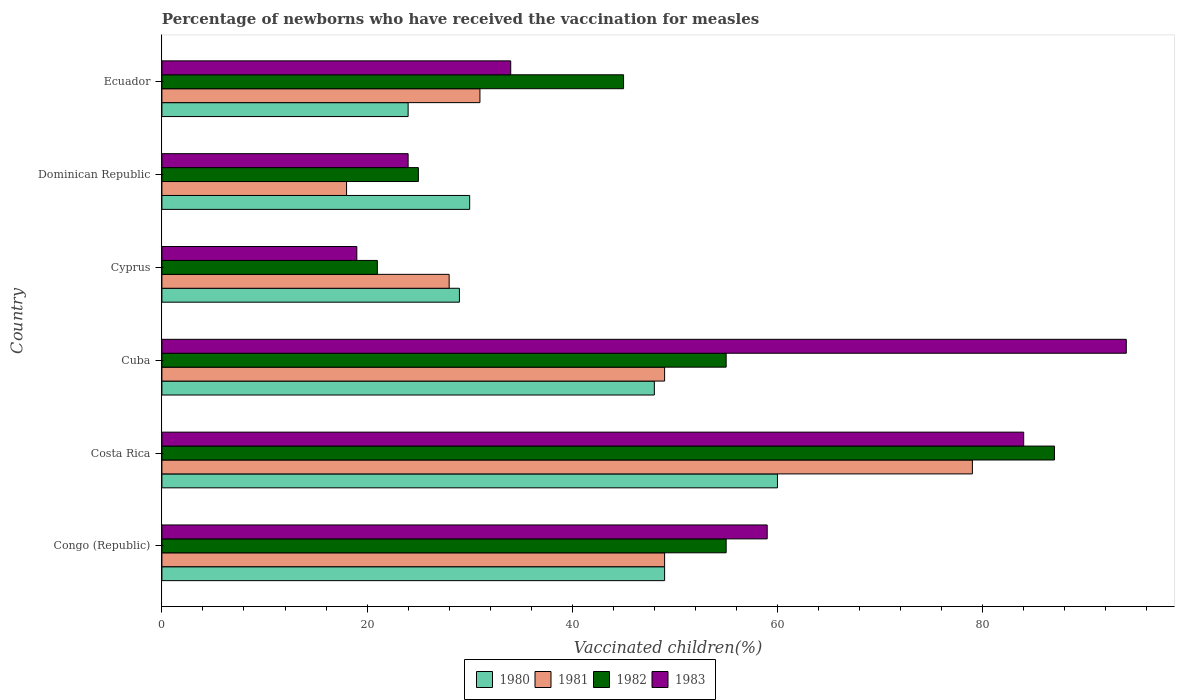How many different coloured bars are there?
Give a very brief answer. 4. Are the number of bars per tick equal to the number of legend labels?
Offer a terse response. Yes. Are the number of bars on each tick of the Y-axis equal?
Keep it short and to the point. Yes. How many bars are there on the 2nd tick from the top?
Provide a succinct answer. 4. What is the label of the 5th group of bars from the top?
Provide a succinct answer. Costa Rica. In how many cases, is the number of bars for a given country not equal to the number of legend labels?
Make the answer very short. 0. What is the percentage of vaccinated children in 1983 in Cyprus?
Offer a very short reply. 19. Across all countries, what is the minimum percentage of vaccinated children in 1982?
Offer a terse response. 21. In which country was the percentage of vaccinated children in 1983 minimum?
Keep it short and to the point. Cyprus. What is the total percentage of vaccinated children in 1980 in the graph?
Ensure brevity in your answer.  240. What is the average percentage of vaccinated children in 1982 per country?
Give a very brief answer. 48. What is the difference between the percentage of vaccinated children in 1980 and percentage of vaccinated children in 1982 in Congo (Republic)?
Offer a very short reply. -6. In how many countries, is the percentage of vaccinated children in 1981 greater than 44 %?
Ensure brevity in your answer.  3. What is the ratio of the percentage of vaccinated children in 1982 in Congo (Republic) to that in Costa Rica?
Offer a very short reply. 0.63. What is the difference between the highest and the second highest percentage of vaccinated children in 1980?
Your answer should be compact. 11. What is the difference between the highest and the lowest percentage of vaccinated children in 1981?
Provide a short and direct response. 61. In how many countries, is the percentage of vaccinated children in 1981 greater than the average percentage of vaccinated children in 1981 taken over all countries?
Your response must be concise. 3. Is the sum of the percentage of vaccinated children in 1980 in Congo (Republic) and Ecuador greater than the maximum percentage of vaccinated children in 1982 across all countries?
Offer a very short reply. No. What does the 2nd bar from the bottom in Cuba represents?
Offer a very short reply. 1981. How many countries are there in the graph?
Your answer should be compact. 6. What is the difference between two consecutive major ticks on the X-axis?
Give a very brief answer. 20. Does the graph contain any zero values?
Your response must be concise. No. Does the graph contain grids?
Offer a terse response. No. How many legend labels are there?
Offer a very short reply. 4. What is the title of the graph?
Keep it short and to the point. Percentage of newborns who have received the vaccination for measles. Does "2014" appear as one of the legend labels in the graph?
Provide a short and direct response. No. What is the label or title of the X-axis?
Provide a succinct answer. Vaccinated children(%). What is the Vaccinated children(%) of 1981 in Congo (Republic)?
Offer a very short reply. 49. What is the Vaccinated children(%) of 1983 in Congo (Republic)?
Offer a terse response. 59. What is the Vaccinated children(%) in 1980 in Costa Rica?
Provide a succinct answer. 60. What is the Vaccinated children(%) of 1981 in Costa Rica?
Keep it short and to the point. 79. What is the Vaccinated children(%) in 1980 in Cuba?
Your answer should be very brief. 48. What is the Vaccinated children(%) of 1981 in Cuba?
Keep it short and to the point. 49. What is the Vaccinated children(%) in 1983 in Cuba?
Ensure brevity in your answer.  94. What is the Vaccinated children(%) of 1980 in Cyprus?
Ensure brevity in your answer.  29. What is the Vaccinated children(%) in 1981 in Cyprus?
Provide a succinct answer. 28. What is the Vaccinated children(%) in 1982 in Cyprus?
Your answer should be compact. 21. What is the Vaccinated children(%) in 1981 in Dominican Republic?
Your response must be concise. 18. What is the Vaccinated children(%) in 1982 in Dominican Republic?
Offer a very short reply. 25. What is the Vaccinated children(%) in 1980 in Ecuador?
Give a very brief answer. 24. What is the Vaccinated children(%) in 1982 in Ecuador?
Ensure brevity in your answer.  45. What is the Vaccinated children(%) in 1983 in Ecuador?
Make the answer very short. 34. Across all countries, what is the maximum Vaccinated children(%) in 1980?
Your answer should be very brief. 60. Across all countries, what is the maximum Vaccinated children(%) of 1981?
Offer a very short reply. 79. Across all countries, what is the maximum Vaccinated children(%) of 1982?
Your answer should be very brief. 87. Across all countries, what is the maximum Vaccinated children(%) of 1983?
Provide a succinct answer. 94. Across all countries, what is the minimum Vaccinated children(%) of 1982?
Your answer should be compact. 21. What is the total Vaccinated children(%) in 1980 in the graph?
Ensure brevity in your answer.  240. What is the total Vaccinated children(%) of 1981 in the graph?
Your answer should be compact. 254. What is the total Vaccinated children(%) of 1982 in the graph?
Give a very brief answer. 288. What is the total Vaccinated children(%) in 1983 in the graph?
Offer a very short reply. 314. What is the difference between the Vaccinated children(%) in 1981 in Congo (Republic) and that in Costa Rica?
Provide a short and direct response. -30. What is the difference between the Vaccinated children(%) in 1982 in Congo (Republic) and that in Costa Rica?
Provide a succinct answer. -32. What is the difference between the Vaccinated children(%) of 1983 in Congo (Republic) and that in Cuba?
Offer a very short reply. -35. What is the difference between the Vaccinated children(%) in 1981 in Congo (Republic) and that in Cyprus?
Make the answer very short. 21. What is the difference between the Vaccinated children(%) of 1980 in Congo (Republic) and that in Dominican Republic?
Provide a succinct answer. 19. What is the difference between the Vaccinated children(%) in 1981 in Congo (Republic) and that in Dominican Republic?
Offer a very short reply. 31. What is the difference between the Vaccinated children(%) in 1982 in Congo (Republic) and that in Dominican Republic?
Make the answer very short. 30. What is the difference between the Vaccinated children(%) in 1983 in Congo (Republic) and that in Dominican Republic?
Provide a short and direct response. 35. What is the difference between the Vaccinated children(%) in 1980 in Congo (Republic) and that in Ecuador?
Your response must be concise. 25. What is the difference between the Vaccinated children(%) in 1981 in Congo (Republic) and that in Ecuador?
Your answer should be compact. 18. What is the difference between the Vaccinated children(%) of 1980 in Costa Rica and that in Cuba?
Ensure brevity in your answer.  12. What is the difference between the Vaccinated children(%) in 1981 in Costa Rica and that in Cuba?
Make the answer very short. 30. What is the difference between the Vaccinated children(%) in 1983 in Costa Rica and that in Cuba?
Make the answer very short. -10. What is the difference between the Vaccinated children(%) in 1983 in Costa Rica and that in Cyprus?
Make the answer very short. 65. What is the difference between the Vaccinated children(%) of 1980 in Costa Rica and that in Dominican Republic?
Give a very brief answer. 30. What is the difference between the Vaccinated children(%) of 1982 in Costa Rica and that in Dominican Republic?
Your response must be concise. 62. What is the difference between the Vaccinated children(%) of 1983 in Costa Rica and that in Dominican Republic?
Your answer should be very brief. 60. What is the difference between the Vaccinated children(%) in 1981 in Costa Rica and that in Ecuador?
Keep it short and to the point. 48. What is the difference between the Vaccinated children(%) in 1983 in Costa Rica and that in Ecuador?
Your response must be concise. 50. What is the difference between the Vaccinated children(%) of 1980 in Cuba and that in Dominican Republic?
Your answer should be compact. 18. What is the difference between the Vaccinated children(%) of 1982 in Cuba and that in Dominican Republic?
Ensure brevity in your answer.  30. What is the difference between the Vaccinated children(%) in 1980 in Cuba and that in Ecuador?
Your answer should be very brief. 24. What is the difference between the Vaccinated children(%) in 1981 in Cuba and that in Ecuador?
Keep it short and to the point. 18. What is the difference between the Vaccinated children(%) of 1982 in Cuba and that in Ecuador?
Your answer should be very brief. 10. What is the difference between the Vaccinated children(%) in 1983 in Cuba and that in Ecuador?
Your answer should be very brief. 60. What is the difference between the Vaccinated children(%) in 1982 in Cyprus and that in Dominican Republic?
Provide a succinct answer. -4. What is the difference between the Vaccinated children(%) of 1980 in Cyprus and that in Ecuador?
Your answer should be compact. 5. What is the difference between the Vaccinated children(%) of 1981 in Cyprus and that in Ecuador?
Your answer should be compact. -3. What is the difference between the Vaccinated children(%) in 1982 in Cyprus and that in Ecuador?
Provide a short and direct response. -24. What is the difference between the Vaccinated children(%) in 1983 in Cyprus and that in Ecuador?
Provide a succinct answer. -15. What is the difference between the Vaccinated children(%) in 1981 in Dominican Republic and that in Ecuador?
Provide a succinct answer. -13. What is the difference between the Vaccinated children(%) in 1983 in Dominican Republic and that in Ecuador?
Keep it short and to the point. -10. What is the difference between the Vaccinated children(%) in 1980 in Congo (Republic) and the Vaccinated children(%) in 1981 in Costa Rica?
Provide a succinct answer. -30. What is the difference between the Vaccinated children(%) in 1980 in Congo (Republic) and the Vaccinated children(%) in 1982 in Costa Rica?
Provide a succinct answer. -38. What is the difference between the Vaccinated children(%) in 1980 in Congo (Republic) and the Vaccinated children(%) in 1983 in Costa Rica?
Provide a succinct answer. -35. What is the difference between the Vaccinated children(%) of 1981 in Congo (Republic) and the Vaccinated children(%) of 1982 in Costa Rica?
Make the answer very short. -38. What is the difference between the Vaccinated children(%) in 1981 in Congo (Republic) and the Vaccinated children(%) in 1983 in Costa Rica?
Offer a terse response. -35. What is the difference between the Vaccinated children(%) in 1982 in Congo (Republic) and the Vaccinated children(%) in 1983 in Costa Rica?
Your answer should be very brief. -29. What is the difference between the Vaccinated children(%) of 1980 in Congo (Republic) and the Vaccinated children(%) of 1983 in Cuba?
Give a very brief answer. -45. What is the difference between the Vaccinated children(%) of 1981 in Congo (Republic) and the Vaccinated children(%) of 1982 in Cuba?
Keep it short and to the point. -6. What is the difference between the Vaccinated children(%) in 1981 in Congo (Republic) and the Vaccinated children(%) in 1983 in Cuba?
Give a very brief answer. -45. What is the difference between the Vaccinated children(%) of 1982 in Congo (Republic) and the Vaccinated children(%) of 1983 in Cuba?
Ensure brevity in your answer.  -39. What is the difference between the Vaccinated children(%) of 1980 in Congo (Republic) and the Vaccinated children(%) of 1983 in Cyprus?
Give a very brief answer. 30. What is the difference between the Vaccinated children(%) of 1981 in Congo (Republic) and the Vaccinated children(%) of 1982 in Cyprus?
Your answer should be compact. 28. What is the difference between the Vaccinated children(%) of 1981 in Congo (Republic) and the Vaccinated children(%) of 1983 in Cyprus?
Offer a terse response. 30. What is the difference between the Vaccinated children(%) of 1982 in Congo (Republic) and the Vaccinated children(%) of 1983 in Cyprus?
Keep it short and to the point. 36. What is the difference between the Vaccinated children(%) of 1980 in Congo (Republic) and the Vaccinated children(%) of 1981 in Dominican Republic?
Give a very brief answer. 31. What is the difference between the Vaccinated children(%) of 1980 in Congo (Republic) and the Vaccinated children(%) of 1982 in Dominican Republic?
Your response must be concise. 24. What is the difference between the Vaccinated children(%) in 1981 in Congo (Republic) and the Vaccinated children(%) in 1983 in Dominican Republic?
Make the answer very short. 25. What is the difference between the Vaccinated children(%) in 1982 in Congo (Republic) and the Vaccinated children(%) in 1983 in Dominican Republic?
Keep it short and to the point. 31. What is the difference between the Vaccinated children(%) in 1980 in Congo (Republic) and the Vaccinated children(%) in 1981 in Ecuador?
Provide a short and direct response. 18. What is the difference between the Vaccinated children(%) of 1980 in Congo (Republic) and the Vaccinated children(%) of 1982 in Ecuador?
Make the answer very short. 4. What is the difference between the Vaccinated children(%) of 1980 in Congo (Republic) and the Vaccinated children(%) of 1983 in Ecuador?
Give a very brief answer. 15. What is the difference between the Vaccinated children(%) in 1981 in Congo (Republic) and the Vaccinated children(%) in 1983 in Ecuador?
Make the answer very short. 15. What is the difference between the Vaccinated children(%) of 1980 in Costa Rica and the Vaccinated children(%) of 1981 in Cuba?
Provide a short and direct response. 11. What is the difference between the Vaccinated children(%) of 1980 in Costa Rica and the Vaccinated children(%) of 1983 in Cuba?
Your answer should be compact. -34. What is the difference between the Vaccinated children(%) of 1981 in Costa Rica and the Vaccinated children(%) of 1982 in Cuba?
Provide a short and direct response. 24. What is the difference between the Vaccinated children(%) in 1981 in Costa Rica and the Vaccinated children(%) in 1983 in Cuba?
Keep it short and to the point. -15. What is the difference between the Vaccinated children(%) of 1982 in Costa Rica and the Vaccinated children(%) of 1983 in Cuba?
Your answer should be compact. -7. What is the difference between the Vaccinated children(%) of 1980 in Costa Rica and the Vaccinated children(%) of 1983 in Cyprus?
Your response must be concise. 41. What is the difference between the Vaccinated children(%) in 1981 in Costa Rica and the Vaccinated children(%) in 1982 in Cyprus?
Offer a terse response. 58. What is the difference between the Vaccinated children(%) of 1981 in Costa Rica and the Vaccinated children(%) of 1983 in Cyprus?
Offer a terse response. 60. What is the difference between the Vaccinated children(%) of 1980 in Costa Rica and the Vaccinated children(%) of 1982 in Dominican Republic?
Give a very brief answer. 35. What is the difference between the Vaccinated children(%) in 1980 in Costa Rica and the Vaccinated children(%) in 1983 in Dominican Republic?
Offer a very short reply. 36. What is the difference between the Vaccinated children(%) in 1981 in Costa Rica and the Vaccinated children(%) in 1983 in Dominican Republic?
Ensure brevity in your answer.  55. What is the difference between the Vaccinated children(%) in 1982 in Costa Rica and the Vaccinated children(%) in 1983 in Dominican Republic?
Offer a terse response. 63. What is the difference between the Vaccinated children(%) in 1980 in Costa Rica and the Vaccinated children(%) in 1982 in Ecuador?
Ensure brevity in your answer.  15. What is the difference between the Vaccinated children(%) in 1980 in Costa Rica and the Vaccinated children(%) in 1983 in Ecuador?
Your response must be concise. 26. What is the difference between the Vaccinated children(%) in 1981 in Costa Rica and the Vaccinated children(%) in 1982 in Ecuador?
Provide a succinct answer. 34. What is the difference between the Vaccinated children(%) in 1982 in Costa Rica and the Vaccinated children(%) in 1983 in Ecuador?
Ensure brevity in your answer.  53. What is the difference between the Vaccinated children(%) in 1980 in Cuba and the Vaccinated children(%) in 1982 in Cyprus?
Provide a succinct answer. 27. What is the difference between the Vaccinated children(%) of 1981 in Cuba and the Vaccinated children(%) of 1983 in Cyprus?
Your response must be concise. 30. What is the difference between the Vaccinated children(%) of 1980 in Cuba and the Vaccinated children(%) of 1982 in Dominican Republic?
Your response must be concise. 23. What is the difference between the Vaccinated children(%) in 1981 in Cuba and the Vaccinated children(%) in 1982 in Dominican Republic?
Your answer should be very brief. 24. What is the difference between the Vaccinated children(%) in 1982 in Cuba and the Vaccinated children(%) in 1983 in Dominican Republic?
Provide a succinct answer. 31. What is the difference between the Vaccinated children(%) in 1980 in Cuba and the Vaccinated children(%) in 1981 in Ecuador?
Give a very brief answer. 17. What is the difference between the Vaccinated children(%) in 1980 in Cuba and the Vaccinated children(%) in 1983 in Ecuador?
Ensure brevity in your answer.  14. What is the difference between the Vaccinated children(%) in 1981 in Cuba and the Vaccinated children(%) in 1982 in Ecuador?
Offer a terse response. 4. What is the difference between the Vaccinated children(%) of 1981 in Cuba and the Vaccinated children(%) of 1983 in Ecuador?
Offer a very short reply. 15. What is the difference between the Vaccinated children(%) in 1982 in Cuba and the Vaccinated children(%) in 1983 in Ecuador?
Your response must be concise. 21. What is the difference between the Vaccinated children(%) of 1980 in Cyprus and the Vaccinated children(%) of 1981 in Dominican Republic?
Make the answer very short. 11. What is the difference between the Vaccinated children(%) in 1980 in Cyprus and the Vaccinated children(%) in 1983 in Dominican Republic?
Keep it short and to the point. 5. What is the difference between the Vaccinated children(%) of 1981 in Cyprus and the Vaccinated children(%) of 1982 in Dominican Republic?
Provide a succinct answer. 3. What is the difference between the Vaccinated children(%) of 1981 in Cyprus and the Vaccinated children(%) of 1983 in Dominican Republic?
Provide a succinct answer. 4. What is the difference between the Vaccinated children(%) in 1980 in Cyprus and the Vaccinated children(%) in 1983 in Ecuador?
Your response must be concise. -5. What is the difference between the Vaccinated children(%) of 1981 in Cyprus and the Vaccinated children(%) of 1983 in Ecuador?
Give a very brief answer. -6. What is the difference between the Vaccinated children(%) in 1982 in Cyprus and the Vaccinated children(%) in 1983 in Ecuador?
Provide a short and direct response. -13. What is the difference between the Vaccinated children(%) of 1980 in Dominican Republic and the Vaccinated children(%) of 1982 in Ecuador?
Offer a very short reply. -15. What is the difference between the Vaccinated children(%) in 1980 in Dominican Republic and the Vaccinated children(%) in 1983 in Ecuador?
Ensure brevity in your answer.  -4. What is the difference between the Vaccinated children(%) in 1981 in Dominican Republic and the Vaccinated children(%) in 1983 in Ecuador?
Your answer should be very brief. -16. What is the difference between the Vaccinated children(%) of 1982 in Dominican Republic and the Vaccinated children(%) of 1983 in Ecuador?
Make the answer very short. -9. What is the average Vaccinated children(%) in 1981 per country?
Ensure brevity in your answer.  42.33. What is the average Vaccinated children(%) of 1983 per country?
Give a very brief answer. 52.33. What is the difference between the Vaccinated children(%) of 1980 and Vaccinated children(%) of 1981 in Congo (Republic)?
Your answer should be compact. 0. What is the difference between the Vaccinated children(%) in 1980 and Vaccinated children(%) in 1983 in Congo (Republic)?
Ensure brevity in your answer.  -10. What is the difference between the Vaccinated children(%) of 1980 and Vaccinated children(%) of 1981 in Costa Rica?
Make the answer very short. -19. What is the difference between the Vaccinated children(%) in 1980 and Vaccinated children(%) in 1983 in Costa Rica?
Make the answer very short. -24. What is the difference between the Vaccinated children(%) in 1981 and Vaccinated children(%) in 1983 in Costa Rica?
Provide a succinct answer. -5. What is the difference between the Vaccinated children(%) of 1980 and Vaccinated children(%) of 1983 in Cuba?
Make the answer very short. -46. What is the difference between the Vaccinated children(%) in 1981 and Vaccinated children(%) in 1982 in Cuba?
Provide a short and direct response. -6. What is the difference between the Vaccinated children(%) of 1981 and Vaccinated children(%) of 1983 in Cuba?
Ensure brevity in your answer.  -45. What is the difference between the Vaccinated children(%) of 1982 and Vaccinated children(%) of 1983 in Cuba?
Your answer should be very brief. -39. What is the difference between the Vaccinated children(%) of 1981 and Vaccinated children(%) of 1983 in Cyprus?
Your answer should be compact. 9. What is the difference between the Vaccinated children(%) of 1980 and Vaccinated children(%) of 1981 in Dominican Republic?
Provide a short and direct response. 12. What is the difference between the Vaccinated children(%) in 1980 and Vaccinated children(%) in 1982 in Dominican Republic?
Make the answer very short. 5. What is the difference between the Vaccinated children(%) in 1981 and Vaccinated children(%) in 1983 in Dominican Republic?
Ensure brevity in your answer.  -6. What is the difference between the Vaccinated children(%) in 1980 and Vaccinated children(%) in 1983 in Ecuador?
Offer a terse response. -10. What is the difference between the Vaccinated children(%) of 1982 and Vaccinated children(%) of 1983 in Ecuador?
Make the answer very short. 11. What is the ratio of the Vaccinated children(%) in 1980 in Congo (Republic) to that in Costa Rica?
Make the answer very short. 0.82. What is the ratio of the Vaccinated children(%) of 1981 in Congo (Republic) to that in Costa Rica?
Ensure brevity in your answer.  0.62. What is the ratio of the Vaccinated children(%) of 1982 in Congo (Republic) to that in Costa Rica?
Your answer should be compact. 0.63. What is the ratio of the Vaccinated children(%) in 1983 in Congo (Republic) to that in Costa Rica?
Provide a short and direct response. 0.7. What is the ratio of the Vaccinated children(%) in 1980 in Congo (Republic) to that in Cuba?
Provide a short and direct response. 1.02. What is the ratio of the Vaccinated children(%) of 1982 in Congo (Republic) to that in Cuba?
Offer a very short reply. 1. What is the ratio of the Vaccinated children(%) in 1983 in Congo (Republic) to that in Cuba?
Keep it short and to the point. 0.63. What is the ratio of the Vaccinated children(%) in 1980 in Congo (Republic) to that in Cyprus?
Provide a succinct answer. 1.69. What is the ratio of the Vaccinated children(%) of 1982 in Congo (Republic) to that in Cyprus?
Provide a short and direct response. 2.62. What is the ratio of the Vaccinated children(%) in 1983 in Congo (Republic) to that in Cyprus?
Keep it short and to the point. 3.11. What is the ratio of the Vaccinated children(%) in 1980 in Congo (Republic) to that in Dominican Republic?
Give a very brief answer. 1.63. What is the ratio of the Vaccinated children(%) of 1981 in Congo (Republic) to that in Dominican Republic?
Ensure brevity in your answer.  2.72. What is the ratio of the Vaccinated children(%) in 1982 in Congo (Republic) to that in Dominican Republic?
Make the answer very short. 2.2. What is the ratio of the Vaccinated children(%) in 1983 in Congo (Republic) to that in Dominican Republic?
Give a very brief answer. 2.46. What is the ratio of the Vaccinated children(%) in 1980 in Congo (Republic) to that in Ecuador?
Your answer should be compact. 2.04. What is the ratio of the Vaccinated children(%) of 1981 in Congo (Republic) to that in Ecuador?
Offer a very short reply. 1.58. What is the ratio of the Vaccinated children(%) in 1982 in Congo (Republic) to that in Ecuador?
Provide a succinct answer. 1.22. What is the ratio of the Vaccinated children(%) in 1983 in Congo (Republic) to that in Ecuador?
Provide a succinct answer. 1.74. What is the ratio of the Vaccinated children(%) in 1980 in Costa Rica to that in Cuba?
Your response must be concise. 1.25. What is the ratio of the Vaccinated children(%) in 1981 in Costa Rica to that in Cuba?
Your answer should be compact. 1.61. What is the ratio of the Vaccinated children(%) in 1982 in Costa Rica to that in Cuba?
Your answer should be very brief. 1.58. What is the ratio of the Vaccinated children(%) of 1983 in Costa Rica to that in Cuba?
Make the answer very short. 0.89. What is the ratio of the Vaccinated children(%) in 1980 in Costa Rica to that in Cyprus?
Provide a short and direct response. 2.07. What is the ratio of the Vaccinated children(%) in 1981 in Costa Rica to that in Cyprus?
Your response must be concise. 2.82. What is the ratio of the Vaccinated children(%) of 1982 in Costa Rica to that in Cyprus?
Provide a succinct answer. 4.14. What is the ratio of the Vaccinated children(%) in 1983 in Costa Rica to that in Cyprus?
Provide a succinct answer. 4.42. What is the ratio of the Vaccinated children(%) of 1980 in Costa Rica to that in Dominican Republic?
Provide a succinct answer. 2. What is the ratio of the Vaccinated children(%) of 1981 in Costa Rica to that in Dominican Republic?
Make the answer very short. 4.39. What is the ratio of the Vaccinated children(%) of 1982 in Costa Rica to that in Dominican Republic?
Offer a very short reply. 3.48. What is the ratio of the Vaccinated children(%) in 1981 in Costa Rica to that in Ecuador?
Ensure brevity in your answer.  2.55. What is the ratio of the Vaccinated children(%) of 1982 in Costa Rica to that in Ecuador?
Offer a very short reply. 1.93. What is the ratio of the Vaccinated children(%) of 1983 in Costa Rica to that in Ecuador?
Provide a succinct answer. 2.47. What is the ratio of the Vaccinated children(%) of 1980 in Cuba to that in Cyprus?
Provide a short and direct response. 1.66. What is the ratio of the Vaccinated children(%) of 1981 in Cuba to that in Cyprus?
Provide a short and direct response. 1.75. What is the ratio of the Vaccinated children(%) of 1982 in Cuba to that in Cyprus?
Ensure brevity in your answer.  2.62. What is the ratio of the Vaccinated children(%) in 1983 in Cuba to that in Cyprus?
Your answer should be very brief. 4.95. What is the ratio of the Vaccinated children(%) in 1981 in Cuba to that in Dominican Republic?
Ensure brevity in your answer.  2.72. What is the ratio of the Vaccinated children(%) in 1983 in Cuba to that in Dominican Republic?
Your answer should be very brief. 3.92. What is the ratio of the Vaccinated children(%) of 1981 in Cuba to that in Ecuador?
Provide a succinct answer. 1.58. What is the ratio of the Vaccinated children(%) of 1982 in Cuba to that in Ecuador?
Make the answer very short. 1.22. What is the ratio of the Vaccinated children(%) of 1983 in Cuba to that in Ecuador?
Keep it short and to the point. 2.76. What is the ratio of the Vaccinated children(%) of 1980 in Cyprus to that in Dominican Republic?
Provide a succinct answer. 0.97. What is the ratio of the Vaccinated children(%) of 1981 in Cyprus to that in Dominican Republic?
Ensure brevity in your answer.  1.56. What is the ratio of the Vaccinated children(%) in 1982 in Cyprus to that in Dominican Republic?
Provide a succinct answer. 0.84. What is the ratio of the Vaccinated children(%) in 1983 in Cyprus to that in Dominican Republic?
Make the answer very short. 0.79. What is the ratio of the Vaccinated children(%) in 1980 in Cyprus to that in Ecuador?
Provide a succinct answer. 1.21. What is the ratio of the Vaccinated children(%) in 1981 in Cyprus to that in Ecuador?
Offer a very short reply. 0.9. What is the ratio of the Vaccinated children(%) of 1982 in Cyprus to that in Ecuador?
Offer a terse response. 0.47. What is the ratio of the Vaccinated children(%) of 1983 in Cyprus to that in Ecuador?
Ensure brevity in your answer.  0.56. What is the ratio of the Vaccinated children(%) of 1980 in Dominican Republic to that in Ecuador?
Your response must be concise. 1.25. What is the ratio of the Vaccinated children(%) in 1981 in Dominican Republic to that in Ecuador?
Keep it short and to the point. 0.58. What is the ratio of the Vaccinated children(%) in 1982 in Dominican Republic to that in Ecuador?
Your answer should be very brief. 0.56. What is the ratio of the Vaccinated children(%) of 1983 in Dominican Republic to that in Ecuador?
Your answer should be compact. 0.71. What is the difference between the highest and the second highest Vaccinated children(%) in 1980?
Offer a very short reply. 11. What is the difference between the highest and the second highest Vaccinated children(%) in 1982?
Provide a short and direct response. 32. What is the difference between the highest and the lowest Vaccinated children(%) in 1981?
Give a very brief answer. 61. What is the difference between the highest and the lowest Vaccinated children(%) in 1983?
Your answer should be very brief. 75. 